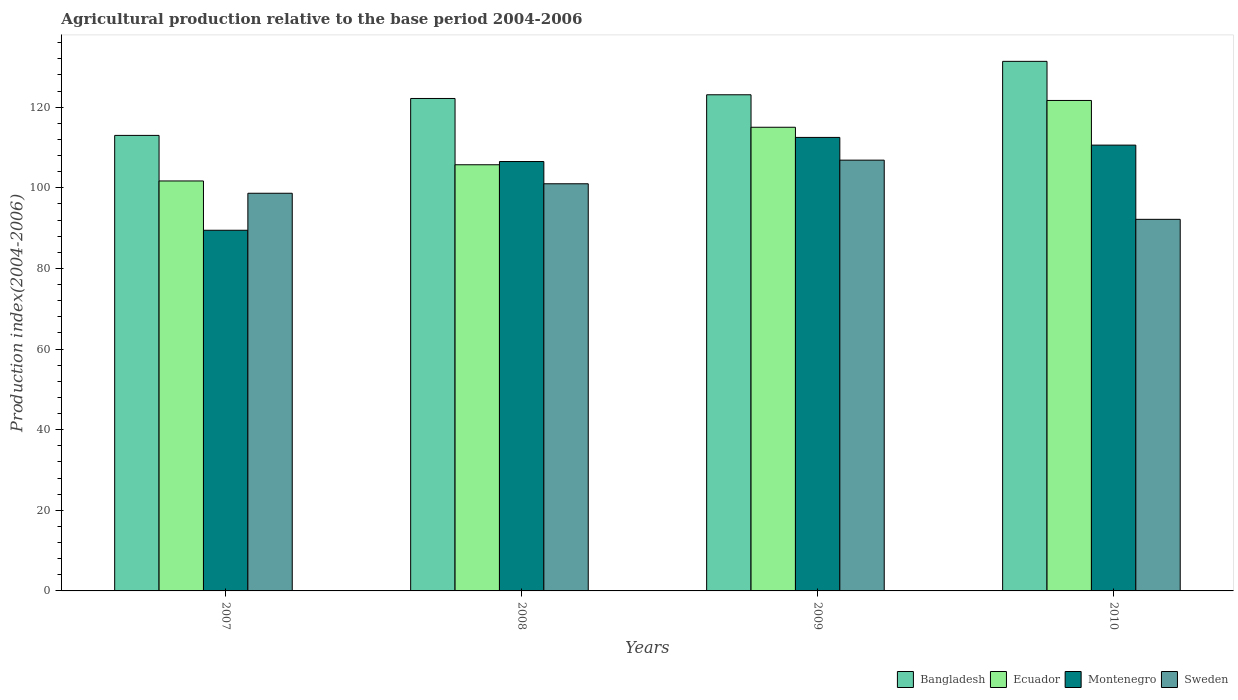How many different coloured bars are there?
Offer a terse response. 4. How many groups of bars are there?
Offer a very short reply. 4. Are the number of bars per tick equal to the number of legend labels?
Provide a short and direct response. Yes. How many bars are there on the 4th tick from the left?
Your answer should be very brief. 4. What is the label of the 4th group of bars from the left?
Your answer should be very brief. 2010. In how many cases, is the number of bars for a given year not equal to the number of legend labels?
Offer a terse response. 0. What is the agricultural production index in Ecuador in 2007?
Provide a succinct answer. 101.7. Across all years, what is the maximum agricultural production index in Montenegro?
Ensure brevity in your answer.  112.5. Across all years, what is the minimum agricultural production index in Ecuador?
Ensure brevity in your answer.  101.7. In which year was the agricultural production index in Montenegro maximum?
Keep it short and to the point. 2009. In which year was the agricultural production index in Bangladesh minimum?
Keep it short and to the point. 2007. What is the total agricultural production index in Sweden in the graph?
Offer a very short reply. 398.69. What is the difference between the agricultural production index in Sweden in 2007 and that in 2008?
Offer a very short reply. -2.35. What is the difference between the agricultural production index in Bangladesh in 2008 and the agricultural production index in Ecuador in 2009?
Offer a very short reply. 7.14. What is the average agricultural production index in Bangladesh per year?
Your response must be concise. 122.4. In the year 2010, what is the difference between the agricultural production index in Ecuador and agricultural production index in Montenegro?
Make the answer very short. 11.08. In how many years, is the agricultural production index in Ecuador greater than 80?
Offer a terse response. 4. What is the ratio of the agricultural production index in Sweden in 2008 to that in 2009?
Provide a short and direct response. 0.95. What is the difference between the highest and the second highest agricultural production index in Montenegro?
Your answer should be compact. 1.91. What is the difference between the highest and the lowest agricultural production index in Bangladesh?
Your answer should be compact. 18.37. In how many years, is the agricultural production index in Sweden greater than the average agricultural production index in Sweden taken over all years?
Give a very brief answer. 2. Is the sum of the agricultural production index in Sweden in 2007 and 2010 greater than the maximum agricultural production index in Ecuador across all years?
Offer a terse response. Yes. Is it the case that in every year, the sum of the agricultural production index in Montenegro and agricultural production index in Bangladesh is greater than the sum of agricultural production index in Ecuador and agricultural production index in Sweden?
Your response must be concise. No. What does the 2nd bar from the left in 2009 represents?
Ensure brevity in your answer.  Ecuador. What does the 2nd bar from the right in 2007 represents?
Your answer should be compact. Montenegro. Is it the case that in every year, the sum of the agricultural production index in Bangladesh and agricultural production index in Montenegro is greater than the agricultural production index in Ecuador?
Your answer should be very brief. Yes. How many bars are there?
Provide a succinct answer. 16. Are all the bars in the graph horizontal?
Your answer should be very brief. No. How many years are there in the graph?
Offer a terse response. 4. What is the difference between two consecutive major ticks on the Y-axis?
Give a very brief answer. 20. Does the graph contain grids?
Provide a short and direct response. No. How many legend labels are there?
Provide a short and direct response. 4. What is the title of the graph?
Offer a very short reply. Agricultural production relative to the base period 2004-2006. What is the label or title of the X-axis?
Your answer should be very brief. Years. What is the label or title of the Y-axis?
Keep it short and to the point. Production index(2004-2006). What is the Production index(2004-2006) of Bangladesh in 2007?
Offer a very short reply. 113. What is the Production index(2004-2006) of Ecuador in 2007?
Keep it short and to the point. 101.7. What is the Production index(2004-2006) in Montenegro in 2007?
Give a very brief answer. 89.47. What is the Production index(2004-2006) of Sweden in 2007?
Ensure brevity in your answer.  98.65. What is the Production index(2004-2006) of Bangladesh in 2008?
Offer a terse response. 122.16. What is the Production index(2004-2006) of Ecuador in 2008?
Provide a short and direct response. 105.72. What is the Production index(2004-2006) of Montenegro in 2008?
Offer a terse response. 106.52. What is the Production index(2004-2006) in Sweden in 2008?
Your answer should be compact. 101. What is the Production index(2004-2006) of Bangladesh in 2009?
Offer a very short reply. 123.08. What is the Production index(2004-2006) in Ecuador in 2009?
Ensure brevity in your answer.  115.02. What is the Production index(2004-2006) of Montenegro in 2009?
Your response must be concise. 112.5. What is the Production index(2004-2006) in Sweden in 2009?
Offer a very short reply. 106.86. What is the Production index(2004-2006) of Bangladesh in 2010?
Offer a very short reply. 131.37. What is the Production index(2004-2006) of Ecuador in 2010?
Ensure brevity in your answer.  121.67. What is the Production index(2004-2006) in Montenegro in 2010?
Provide a short and direct response. 110.59. What is the Production index(2004-2006) in Sweden in 2010?
Make the answer very short. 92.18. Across all years, what is the maximum Production index(2004-2006) of Bangladesh?
Your answer should be compact. 131.37. Across all years, what is the maximum Production index(2004-2006) in Ecuador?
Provide a short and direct response. 121.67. Across all years, what is the maximum Production index(2004-2006) of Montenegro?
Make the answer very short. 112.5. Across all years, what is the maximum Production index(2004-2006) of Sweden?
Your answer should be very brief. 106.86. Across all years, what is the minimum Production index(2004-2006) in Bangladesh?
Provide a succinct answer. 113. Across all years, what is the minimum Production index(2004-2006) in Ecuador?
Your response must be concise. 101.7. Across all years, what is the minimum Production index(2004-2006) of Montenegro?
Your answer should be compact. 89.47. Across all years, what is the minimum Production index(2004-2006) in Sweden?
Ensure brevity in your answer.  92.18. What is the total Production index(2004-2006) of Bangladesh in the graph?
Make the answer very short. 489.61. What is the total Production index(2004-2006) in Ecuador in the graph?
Provide a short and direct response. 444.11. What is the total Production index(2004-2006) in Montenegro in the graph?
Offer a very short reply. 419.08. What is the total Production index(2004-2006) of Sweden in the graph?
Your answer should be very brief. 398.69. What is the difference between the Production index(2004-2006) in Bangladesh in 2007 and that in 2008?
Make the answer very short. -9.16. What is the difference between the Production index(2004-2006) in Ecuador in 2007 and that in 2008?
Your response must be concise. -4.02. What is the difference between the Production index(2004-2006) in Montenegro in 2007 and that in 2008?
Offer a very short reply. -17.05. What is the difference between the Production index(2004-2006) in Sweden in 2007 and that in 2008?
Make the answer very short. -2.35. What is the difference between the Production index(2004-2006) of Bangladesh in 2007 and that in 2009?
Give a very brief answer. -10.08. What is the difference between the Production index(2004-2006) of Ecuador in 2007 and that in 2009?
Offer a terse response. -13.32. What is the difference between the Production index(2004-2006) of Montenegro in 2007 and that in 2009?
Offer a terse response. -23.03. What is the difference between the Production index(2004-2006) in Sweden in 2007 and that in 2009?
Your answer should be very brief. -8.21. What is the difference between the Production index(2004-2006) of Bangladesh in 2007 and that in 2010?
Offer a terse response. -18.37. What is the difference between the Production index(2004-2006) in Ecuador in 2007 and that in 2010?
Your answer should be compact. -19.97. What is the difference between the Production index(2004-2006) in Montenegro in 2007 and that in 2010?
Your answer should be compact. -21.12. What is the difference between the Production index(2004-2006) of Sweden in 2007 and that in 2010?
Offer a terse response. 6.47. What is the difference between the Production index(2004-2006) of Bangladesh in 2008 and that in 2009?
Provide a short and direct response. -0.92. What is the difference between the Production index(2004-2006) of Ecuador in 2008 and that in 2009?
Offer a terse response. -9.3. What is the difference between the Production index(2004-2006) in Montenegro in 2008 and that in 2009?
Ensure brevity in your answer.  -5.98. What is the difference between the Production index(2004-2006) in Sweden in 2008 and that in 2009?
Your answer should be very brief. -5.86. What is the difference between the Production index(2004-2006) of Bangladesh in 2008 and that in 2010?
Ensure brevity in your answer.  -9.21. What is the difference between the Production index(2004-2006) in Ecuador in 2008 and that in 2010?
Provide a succinct answer. -15.95. What is the difference between the Production index(2004-2006) in Montenegro in 2008 and that in 2010?
Your answer should be very brief. -4.07. What is the difference between the Production index(2004-2006) of Sweden in 2008 and that in 2010?
Your answer should be compact. 8.82. What is the difference between the Production index(2004-2006) of Bangladesh in 2009 and that in 2010?
Your response must be concise. -8.29. What is the difference between the Production index(2004-2006) of Ecuador in 2009 and that in 2010?
Provide a succinct answer. -6.65. What is the difference between the Production index(2004-2006) in Montenegro in 2009 and that in 2010?
Ensure brevity in your answer.  1.91. What is the difference between the Production index(2004-2006) of Sweden in 2009 and that in 2010?
Provide a short and direct response. 14.68. What is the difference between the Production index(2004-2006) in Bangladesh in 2007 and the Production index(2004-2006) in Ecuador in 2008?
Your answer should be compact. 7.28. What is the difference between the Production index(2004-2006) of Bangladesh in 2007 and the Production index(2004-2006) of Montenegro in 2008?
Offer a very short reply. 6.48. What is the difference between the Production index(2004-2006) in Bangladesh in 2007 and the Production index(2004-2006) in Sweden in 2008?
Ensure brevity in your answer.  12. What is the difference between the Production index(2004-2006) of Ecuador in 2007 and the Production index(2004-2006) of Montenegro in 2008?
Your answer should be very brief. -4.82. What is the difference between the Production index(2004-2006) in Ecuador in 2007 and the Production index(2004-2006) in Sweden in 2008?
Your answer should be compact. 0.7. What is the difference between the Production index(2004-2006) in Montenegro in 2007 and the Production index(2004-2006) in Sweden in 2008?
Keep it short and to the point. -11.53. What is the difference between the Production index(2004-2006) of Bangladesh in 2007 and the Production index(2004-2006) of Ecuador in 2009?
Provide a short and direct response. -2.02. What is the difference between the Production index(2004-2006) in Bangladesh in 2007 and the Production index(2004-2006) in Montenegro in 2009?
Give a very brief answer. 0.5. What is the difference between the Production index(2004-2006) of Bangladesh in 2007 and the Production index(2004-2006) of Sweden in 2009?
Offer a very short reply. 6.14. What is the difference between the Production index(2004-2006) in Ecuador in 2007 and the Production index(2004-2006) in Montenegro in 2009?
Provide a succinct answer. -10.8. What is the difference between the Production index(2004-2006) of Ecuador in 2007 and the Production index(2004-2006) of Sweden in 2009?
Your response must be concise. -5.16. What is the difference between the Production index(2004-2006) in Montenegro in 2007 and the Production index(2004-2006) in Sweden in 2009?
Your response must be concise. -17.39. What is the difference between the Production index(2004-2006) in Bangladesh in 2007 and the Production index(2004-2006) in Ecuador in 2010?
Your response must be concise. -8.67. What is the difference between the Production index(2004-2006) of Bangladesh in 2007 and the Production index(2004-2006) of Montenegro in 2010?
Make the answer very short. 2.41. What is the difference between the Production index(2004-2006) in Bangladesh in 2007 and the Production index(2004-2006) in Sweden in 2010?
Provide a succinct answer. 20.82. What is the difference between the Production index(2004-2006) in Ecuador in 2007 and the Production index(2004-2006) in Montenegro in 2010?
Your response must be concise. -8.89. What is the difference between the Production index(2004-2006) in Ecuador in 2007 and the Production index(2004-2006) in Sweden in 2010?
Offer a terse response. 9.52. What is the difference between the Production index(2004-2006) of Montenegro in 2007 and the Production index(2004-2006) of Sweden in 2010?
Your response must be concise. -2.71. What is the difference between the Production index(2004-2006) in Bangladesh in 2008 and the Production index(2004-2006) in Ecuador in 2009?
Provide a succinct answer. 7.14. What is the difference between the Production index(2004-2006) of Bangladesh in 2008 and the Production index(2004-2006) of Montenegro in 2009?
Keep it short and to the point. 9.66. What is the difference between the Production index(2004-2006) of Ecuador in 2008 and the Production index(2004-2006) of Montenegro in 2009?
Offer a terse response. -6.78. What is the difference between the Production index(2004-2006) in Ecuador in 2008 and the Production index(2004-2006) in Sweden in 2009?
Offer a terse response. -1.14. What is the difference between the Production index(2004-2006) in Montenegro in 2008 and the Production index(2004-2006) in Sweden in 2009?
Your answer should be very brief. -0.34. What is the difference between the Production index(2004-2006) in Bangladesh in 2008 and the Production index(2004-2006) in Ecuador in 2010?
Provide a short and direct response. 0.49. What is the difference between the Production index(2004-2006) in Bangladesh in 2008 and the Production index(2004-2006) in Montenegro in 2010?
Keep it short and to the point. 11.57. What is the difference between the Production index(2004-2006) in Bangladesh in 2008 and the Production index(2004-2006) in Sweden in 2010?
Your answer should be very brief. 29.98. What is the difference between the Production index(2004-2006) of Ecuador in 2008 and the Production index(2004-2006) of Montenegro in 2010?
Ensure brevity in your answer.  -4.87. What is the difference between the Production index(2004-2006) of Ecuador in 2008 and the Production index(2004-2006) of Sweden in 2010?
Offer a very short reply. 13.54. What is the difference between the Production index(2004-2006) in Montenegro in 2008 and the Production index(2004-2006) in Sweden in 2010?
Your answer should be very brief. 14.34. What is the difference between the Production index(2004-2006) in Bangladesh in 2009 and the Production index(2004-2006) in Ecuador in 2010?
Your response must be concise. 1.41. What is the difference between the Production index(2004-2006) in Bangladesh in 2009 and the Production index(2004-2006) in Montenegro in 2010?
Provide a short and direct response. 12.49. What is the difference between the Production index(2004-2006) in Bangladesh in 2009 and the Production index(2004-2006) in Sweden in 2010?
Offer a terse response. 30.9. What is the difference between the Production index(2004-2006) of Ecuador in 2009 and the Production index(2004-2006) of Montenegro in 2010?
Make the answer very short. 4.43. What is the difference between the Production index(2004-2006) of Ecuador in 2009 and the Production index(2004-2006) of Sweden in 2010?
Provide a short and direct response. 22.84. What is the difference between the Production index(2004-2006) of Montenegro in 2009 and the Production index(2004-2006) of Sweden in 2010?
Your answer should be very brief. 20.32. What is the average Production index(2004-2006) of Bangladesh per year?
Provide a succinct answer. 122.4. What is the average Production index(2004-2006) of Ecuador per year?
Your answer should be very brief. 111.03. What is the average Production index(2004-2006) of Montenegro per year?
Provide a succinct answer. 104.77. What is the average Production index(2004-2006) of Sweden per year?
Give a very brief answer. 99.67. In the year 2007, what is the difference between the Production index(2004-2006) in Bangladesh and Production index(2004-2006) in Montenegro?
Ensure brevity in your answer.  23.53. In the year 2007, what is the difference between the Production index(2004-2006) in Bangladesh and Production index(2004-2006) in Sweden?
Keep it short and to the point. 14.35. In the year 2007, what is the difference between the Production index(2004-2006) in Ecuador and Production index(2004-2006) in Montenegro?
Provide a succinct answer. 12.23. In the year 2007, what is the difference between the Production index(2004-2006) of Ecuador and Production index(2004-2006) of Sweden?
Your answer should be compact. 3.05. In the year 2007, what is the difference between the Production index(2004-2006) in Montenegro and Production index(2004-2006) in Sweden?
Your answer should be compact. -9.18. In the year 2008, what is the difference between the Production index(2004-2006) of Bangladesh and Production index(2004-2006) of Ecuador?
Your answer should be very brief. 16.44. In the year 2008, what is the difference between the Production index(2004-2006) of Bangladesh and Production index(2004-2006) of Montenegro?
Ensure brevity in your answer.  15.64. In the year 2008, what is the difference between the Production index(2004-2006) of Bangladesh and Production index(2004-2006) of Sweden?
Make the answer very short. 21.16. In the year 2008, what is the difference between the Production index(2004-2006) of Ecuador and Production index(2004-2006) of Sweden?
Your response must be concise. 4.72. In the year 2008, what is the difference between the Production index(2004-2006) of Montenegro and Production index(2004-2006) of Sweden?
Your answer should be compact. 5.52. In the year 2009, what is the difference between the Production index(2004-2006) in Bangladesh and Production index(2004-2006) in Ecuador?
Your answer should be very brief. 8.06. In the year 2009, what is the difference between the Production index(2004-2006) of Bangladesh and Production index(2004-2006) of Montenegro?
Provide a short and direct response. 10.58. In the year 2009, what is the difference between the Production index(2004-2006) in Bangladesh and Production index(2004-2006) in Sweden?
Keep it short and to the point. 16.22. In the year 2009, what is the difference between the Production index(2004-2006) in Ecuador and Production index(2004-2006) in Montenegro?
Your answer should be very brief. 2.52. In the year 2009, what is the difference between the Production index(2004-2006) of Ecuador and Production index(2004-2006) of Sweden?
Offer a very short reply. 8.16. In the year 2009, what is the difference between the Production index(2004-2006) in Montenegro and Production index(2004-2006) in Sweden?
Give a very brief answer. 5.64. In the year 2010, what is the difference between the Production index(2004-2006) of Bangladesh and Production index(2004-2006) of Montenegro?
Your answer should be very brief. 20.78. In the year 2010, what is the difference between the Production index(2004-2006) in Bangladesh and Production index(2004-2006) in Sweden?
Give a very brief answer. 39.19. In the year 2010, what is the difference between the Production index(2004-2006) in Ecuador and Production index(2004-2006) in Montenegro?
Provide a succinct answer. 11.08. In the year 2010, what is the difference between the Production index(2004-2006) in Ecuador and Production index(2004-2006) in Sweden?
Provide a short and direct response. 29.49. In the year 2010, what is the difference between the Production index(2004-2006) in Montenegro and Production index(2004-2006) in Sweden?
Provide a short and direct response. 18.41. What is the ratio of the Production index(2004-2006) in Bangladesh in 2007 to that in 2008?
Provide a succinct answer. 0.93. What is the ratio of the Production index(2004-2006) of Ecuador in 2007 to that in 2008?
Your response must be concise. 0.96. What is the ratio of the Production index(2004-2006) of Montenegro in 2007 to that in 2008?
Ensure brevity in your answer.  0.84. What is the ratio of the Production index(2004-2006) of Sweden in 2007 to that in 2008?
Your answer should be very brief. 0.98. What is the ratio of the Production index(2004-2006) of Bangladesh in 2007 to that in 2009?
Provide a succinct answer. 0.92. What is the ratio of the Production index(2004-2006) of Ecuador in 2007 to that in 2009?
Offer a terse response. 0.88. What is the ratio of the Production index(2004-2006) in Montenegro in 2007 to that in 2009?
Provide a succinct answer. 0.8. What is the ratio of the Production index(2004-2006) in Sweden in 2007 to that in 2009?
Offer a very short reply. 0.92. What is the ratio of the Production index(2004-2006) in Bangladesh in 2007 to that in 2010?
Provide a short and direct response. 0.86. What is the ratio of the Production index(2004-2006) of Ecuador in 2007 to that in 2010?
Your response must be concise. 0.84. What is the ratio of the Production index(2004-2006) of Montenegro in 2007 to that in 2010?
Keep it short and to the point. 0.81. What is the ratio of the Production index(2004-2006) in Sweden in 2007 to that in 2010?
Offer a very short reply. 1.07. What is the ratio of the Production index(2004-2006) in Bangladesh in 2008 to that in 2009?
Offer a very short reply. 0.99. What is the ratio of the Production index(2004-2006) of Ecuador in 2008 to that in 2009?
Provide a succinct answer. 0.92. What is the ratio of the Production index(2004-2006) of Montenegro in 2008 to that in 2009?
Make the answer very short. 0.95. What is the ratio of the Production index(2004-2006) of Sweden in 2008 to that in 2009?
Give a very brief answer. 0.95. What is the ratio of the Production index(2004-2006) in Bangladesh in 2008 to that in 2010?
Provide a succinct answer. 0.93. What is the ratio of the Production index(2004-2006) in Ecuador in 2008 to that in 2010?
Provide a succinct answer. 0.87. What is the ratio of the Production index(2004-2006) in Montenegro in 2008 to that in 2010?
Your response must be concise. 0.96. What is the ratio of the Production index(2004-2006) of Sweden in 2008 to that in 2010?
Make the answer very short. 1.1. What is the ratio of the Production index(2004-2006) in Bangladesh in 2009 to that in 2010?
Your answer should be very brief. 0.94. What is the ratio of the Production index(2004-2006) in Ecuador in 2009 to that in 2010?
Offer a very short reply. 0.95. What is the ratio of the Production index(2004-2006) of Montenegro in 2009 to that in 2010?
Your answer should be very brief. 1.02. What is the ratio of the Production index(2004-2006) of Sweden in 2009 to that in 2010?
Your answer should be compact. 1.16. What is the difference between the highest and the second highest Production index(2004-2006) in Bangladesh?
Keep it short and to the point. 8.29. What is the difference between the highest and the second highest Production index(2004-2006) of Ecuador?
Your answer should be very brief. 6.65. What is the difference between the highest and the second highest Production index(2004-2006) in Montenegro?
Offer a terse response. 1.91. What is the difference between the highest and the second highest Production index(2004-2006) of Sweden?
Make the answer very short. 5.86. What is the difference between the highest and the lowest Production index(2004-2006) in Bangladesh?
Your answer should be compact. 18.37. What is the difference between the highest and the lowest Production index(2004-2006) of Ecuador?
Ensure brevity in your answer.  19.97. What is the difference between the highest and the lowest Production index(2004-2006) in Montenegro?
Your answer should be compact. 23.03. What is the difference between the highest and the lowest Production index(2004-2006) of Sweden?
Offer a very short reply. 14.68. 